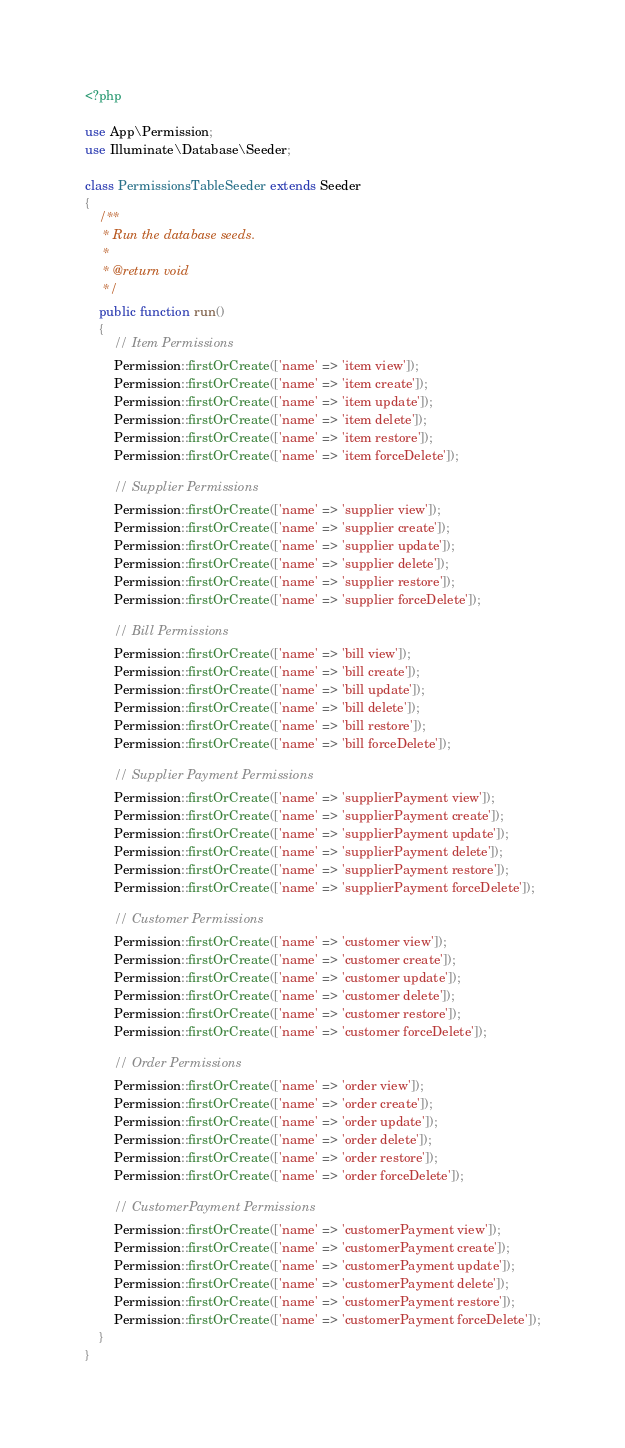Convert code to text. <code><loc_0><loc_0><loc_500><loc_500><_PHP_><?php

use App\Permission;
use Illuminate\Database\Seeder;

class PermissionsTableSeeder extends Seeder
{
    /**
     * Run the database seeds.
     *
     * @return void
     */
    public function run()
    {
        // Item Permissions
        Permission::firstOrCreate(['name' => 'item view']);
        Permission::firstOrCreate(['name' => 'item create']);
        Permission::firstOrCreate(['name' => 'item update']);
        Permission::firstOrCreate(['name' => 'item delete']);
        Permission::firstOrCreate(['name' => 'item restore']);
        Permission::firstOrCreate(['name' => 'item forceDelete']);

        // Supplier Permissions
        Permission::firstOrCreate(['name' => 'supplier view']);
        Permission::firstOrCreate(['name' => 'supplier create']);
        Permission::firstOrCreate(['name' => 'supplier update']);
        Permission::firstOrCreate(['name' => 'supplier delete']);
        Permission::firstOrCreate(['name' => 'supplier restore']);
        Permission::firstOrCreate(['name' => 'supplier forceDelete']);

        // Bill Permissions
        Permission::firstOrCreate(['name' => 'bill view']);
        Permission::firstOrCreate(['name' => 'bill create']);
        Permission::firstOrCreate(['name' => 'bill update']);
        Permission::firstOrCreate(['name' => 'bill delete']);
        Permission::firstOrCreate(['name' => 'bill restore']);
        Permission::firstOrCreate(['name' => 'bill forceDelete']);

        // Supplier Payment Permissions
        Permission::firstOrCreate(['name' => 'supplierPayment view']);
        Permission::firstOrCreate(['name' => 'supplierPayment create']);
        Permission::firstOrCreate(['name' => 'supplierPayment update']);
        Permission::firstOrCreate(['name' => 'supplierPayment delete']);
        Permission::firstOrCreate(['name' => 'supplierPayment restore']);
        Permission::firstOrCreate(['name' => 'supplierPayment forceDelete']);

        // Customer Permissions
        Permission::firstOrCreate(['name' => 'customer view']);
        Permission::firstOrCreate(['name' => 'customer create']);
        Permission::firstOrCreate(['name' => 'customer update']);
        Permission::firstOrCreate(['name' => 'customer delete']);
        Permission::firstOrCreate(['name' => 'customer restore']);
        Permission::firstOrCreate(['name' => 'customer forceDelete']);

        // Order Permissions
        Permission::firstOrCreate(['name' => 'order view']);
        Permission::firstOrCreate(['name' => 'order create']);
        Permission::firstOrCreate(['name' => 'order update']);
        Permission::firstOrCreate(['name' => 'order delete']);
        Permission::firstOrCreate(['name' => 'order restore']);
        Permission::firstOrCreate(['name' => 'order forceDelete']);

        // CustomerPayment Permissions
        Permission::firstOrCreate(['name' => 'customerPayment view']);
        Permission::firstOrCreate(['name' => 'customerPayment create']);
        Permission::firstOrCreate(['name' => 'customerPayment update']);
        Permission::firstOrCreate(['name' => 'customerPayment delete']);
        Permission::firstOrCreate(['name' => 'customerPayment restore']);
        Permission::firstOrCreate(['name' => 'customerPayment forceDelete']);
    }
}
</code> 